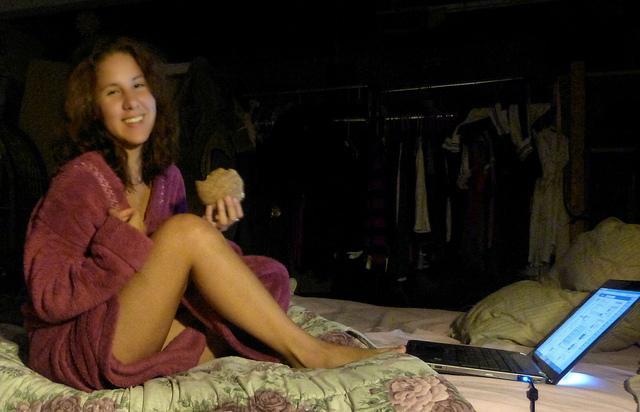How many people are in the picture?
Give a very brief answer. 1. How many beds are there?
Give a very brief answer. 2. 